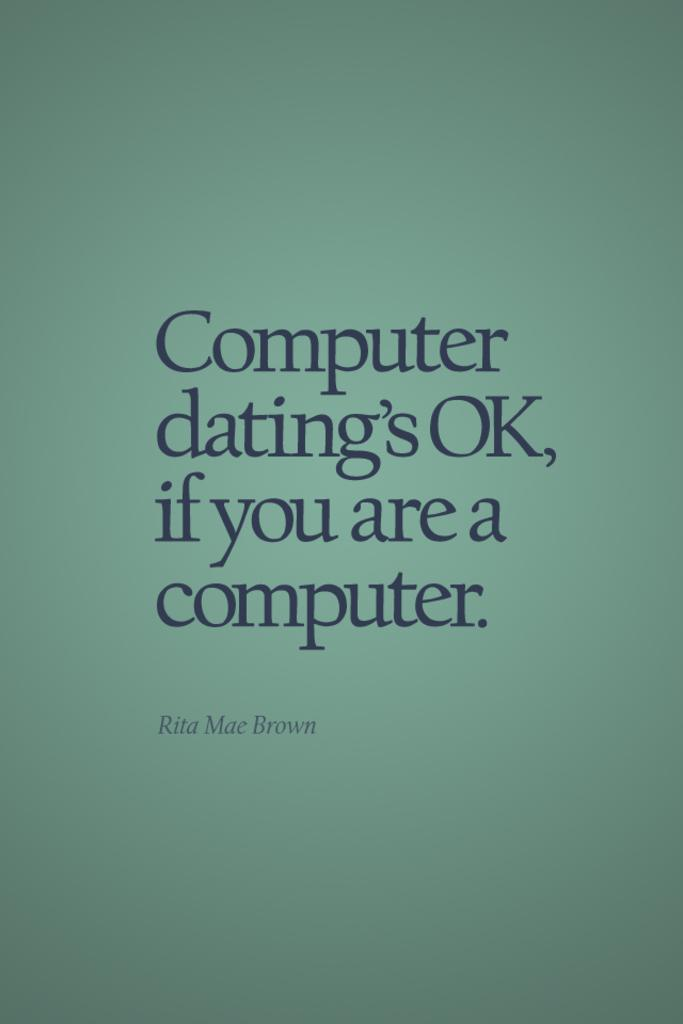Provide a one-sentence caption for the provided image. The cover image of Rita Mae Brown's Computer Dating publication. 